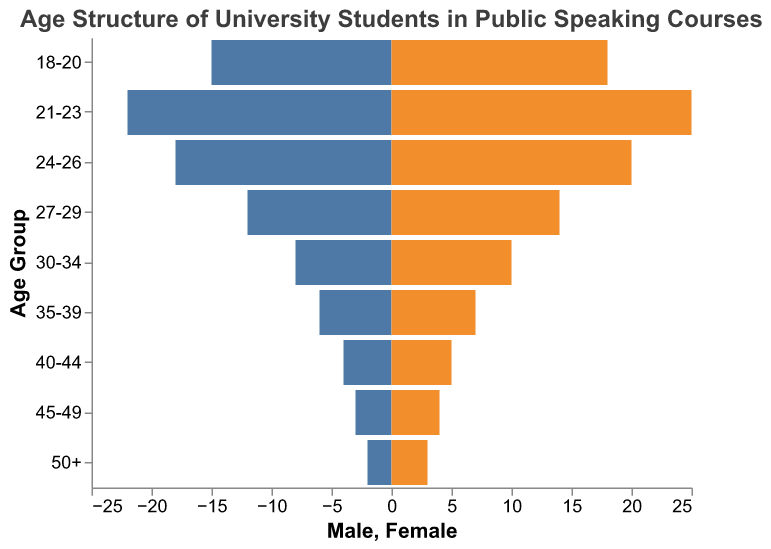What is the age group with the highest number of female students? By looking at the female bar values, the age group with the longest bar is 21-23.
Answer: 21-23 How many more male students are there in the 21-23 age group than in the 18-20 age group? The male bars for the 21-23 age group and the 18-20 age group show values of 22 and 15, respectively. The difference is 22 - 15 = 7.
Answer: 7 In which age group is the gender ratio most balanced? The ratio is determined by comparing the male and female bars across age groups. The 18-20 age group has 15 males and 18 females, and the 21-23 age group has 22 males and 25 females. Both have a similar ratio but the 24-26 age group has a closer difference with 18 males and 20 females.
Answer: 24-26 How many students aged 30 and above are enrolled in the public speaking courses? Summing the male and female students from age groups "30-34", "35-39", "40-44", "45-49", and "50+": (8+10) + (6+7) + (4+5) + (3+4) + (2+3) = 52.
Answer: 52 What is the total number of students in the age group 18-20? Adding the number of males and females in this age group: 15 + 18 = 33.
Answer: 33 Which age group has the smallest total enrollment? The age group with the smallest enrollment can be found by adding the males and females in each group and comparing. The "50+" age group has 2 males and 3 females, totaling 5.
Answer: 50+ How does the number of male students in the 27-29 age group compare to the number of female students in the same group? The male bar in the 27-29 age group shows 12 males, while the female bar shows 14 females, so there are 2 more females than males.
Answer: There are 2 fewer males compared to females Which gender has more students in the age bracket 35-39? The male bar in the 35-39 age group shows 6 males, and the female bar shows 7 females, so there are more female students.
Answer: Female What is the trend in enrollment as age increases? By observing the lengths of the bars, both male and female enrollments show a decreasing trend as the age increases.
Answer: Decreasing trend What is the ratio of male to female students in the "24-26" age group? The male bar in the 24-26 age group shows 18 males, and the female bar shows 20 females. The ratio is 18:20, which simplifies to 9:10.
Answer: 9:10 